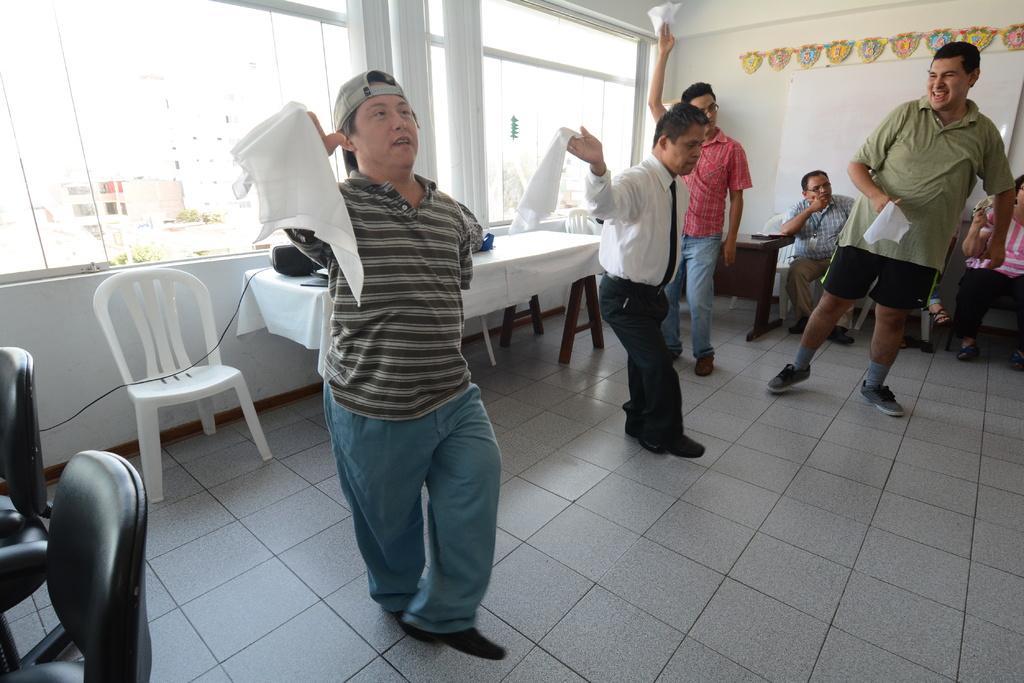Could you give a brief overview of what you see in this image? In the image in the center we can see three persons were standing and they were holding clothes. And they were smiling,which we can see on their faces. In the background there is a wall,glass,garland,tables,cloth,black color object,chairs,few people were sitting and few other objects. Through glass,we can see buildings. 